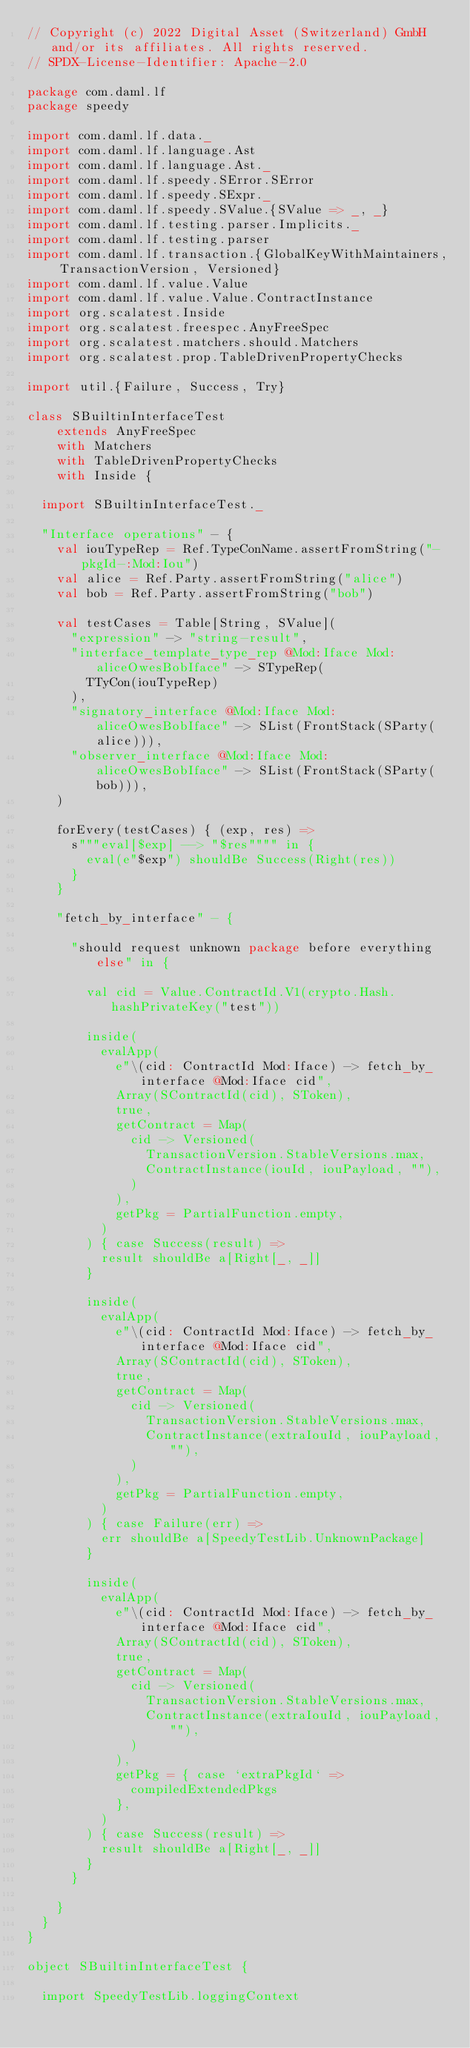<code> <loc_0><loc_0><loc_500><loc_500><_Scala_>// Copyright (c) 2022 Digital Asset (Switzerland) GmbH and/or its affiliates. All rights reserved.
// SPDX-License-Identifier: Apache-2.0

package com.daml.lf
package speedy

import com.daml.lf.data._
import com.daml.lf.language.Ast
import com.daml.lf.language.Ast._
import com.daml.lf.speedy.SError.SError
import com.daml.lf.speedy.SExpr._
import com.daml.lf.speedy.SValue.{SValue => _, _}
import com.daml.lf.testing.parser.Implicits._
import com.daml.lf.testing.parser
import com.daml.lf.transaction.{GlobalKeyWithMaintainers, TransactionVersion, Versioned}
import com.daml.lf.value.Value
import com.daml.lf.value.Value.ContractInstance
import org.scalatest.Inside
import org.scalatest.freespec.AnyFreeSpec
import org.scalatest.matchers.should.Matchers
import org.scalatest.prop.TableDrivenPropertyChecks

import util.{Failure, Success, Try}

class SBuiltinInterfaceTest
    extends AnyFreeSpec
    with Matchers
    with TableDrivenPropertyChecks
    with Inside {

  import SBuiltinInterfaceTest._

  "Interface operations" - {
    val iouTypeRep = Ref.TypeConName.assertFromString("-pkgId-:Mod:Iou")
    val alice = Ref.Party.assertFromString("alice")
    val bob = Ref.Party.assertFromString("bob")

    val testCases = Table[String, SValue](
      "expression" -> "string-result",
      "interface_template_type_rep @Mod:Iface Mod:aliceOwesBobIface" -> STypeRep(
        TTyCon(iouTypeRep)
      ),
      "signatory_interface @Mod:Iface Mod:aliceOwesBobIface" -> SList(FrontStack(SParty(alice))),
      "observer_interface @Mod:Iface Mod:aliceOwesBobIface" -> SList(FrontStack(SParty(bob))),
    )

    forEvery(testCases) { (exp, res) =>
      s"""eval[$exp] --> "$res"""" in {
        eval(e"$exp") shouldBe Success(Right(res))
      }
    }

    "fetch_by_interface" - {

      "should request unknown package before everything else" in {

        val cid = Value.ContractId.V1(crypto.Hash.hashPrivateKey("test"))

        inside(
          evalApp(
            e"\(cid: ContractId Mod:Iface) -> fetch_by_interface @Mod:Iface cid",
            Array(SContractId(cid), SToken),
            true,
            getContract = Map(
              cid -> Versioned(
                TransactionVersion.StableVersions.max,
                ContractInstance(iouId, iouPayload, ""),
              )
            ),
            getPkg = PartialFunction.empty,
          )
        ) { case Success(result) =>
          result shouldBe a[Right[_, _]]
        }

        inside(
          evalApp(
            e"\(cid: ContractId Mod:Iface) -> fetch_by_interface @Mod:Iface cid",
            Array(SContractId(cid), SToken),
            true,
            getContract = Map(
              cid -> Versioned(
                TransactionVersion.StableVersions.max,
                ContractInstance(extraIouId, iouPayload, ""),
              )
            ),
            getPkg = PartialFunction.empty,
          )
        ) { case Failure(err) =>
          err shouldBe a[SpeedyTestLib.UnknownPackage]
        }

        inside(
          evalApp(
            e"\(cid: ContractId Mod:Iface) -> fetch_by_interface @Mod:Iface cid",
            Array(SContractId(cid), SToken),
            true,
            getContract = Map(
              cid -> Versioned(
                TransactionVersion.StableVersions.max,
                ContractInstance(extraIouId, iouPayload, ""),
              )
            ),
            getPkg = { case `extraPkgId` =>
              compiledExtendedPkgs
            },
          )
        ) { case Success(result) =>
          result shouldBe a[Right[_, _]]
        }
      }

    }
  }
}

object SBuiltinInterfaceTest {

  import SpeedyTestLib.loggingContext
</code> 